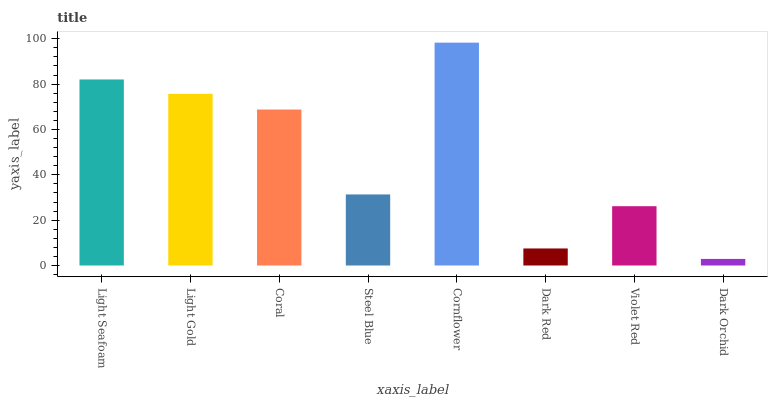Is Dark Orchid the minimum?
Answer yes or no. Yes. Is Cornflower the maximum?
Answer yes or no. Yes. Is Light Gold the minimum?
Answer yes or no. No. Is Light Gold the maximum?
Answer yes or no. No. Is Light Seafoam greater than Light Gold?
Answer yes or no. Yes. Is Light Gold less than Light Seafoam?
Answer yes or no. Yes. Is Light Gold greater than Light Seafoam?
Answer yes or no. No. Is Light Seafoam less than Light Gold?
Answer yes or no. No. Is Coral the high median?
Answer yes or no. Yes. Is Steel Blue the low median?
Answer yes or no. Yes. Is Violet Red the high median?
Answer yes or no. No. Is Violet Red the low median?
Answer yes or no. No. 